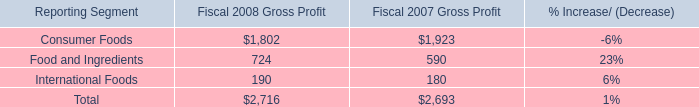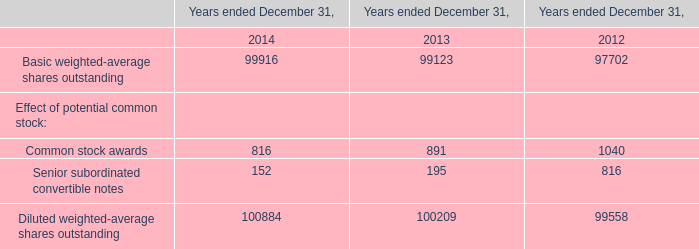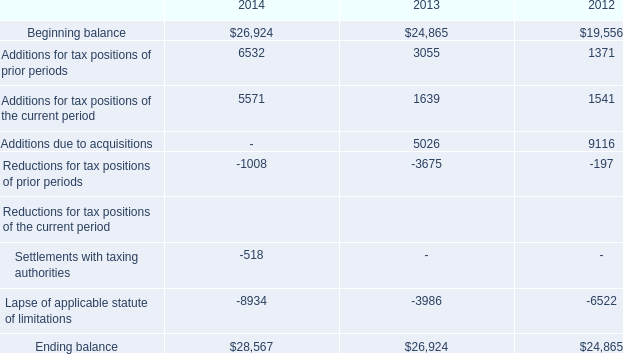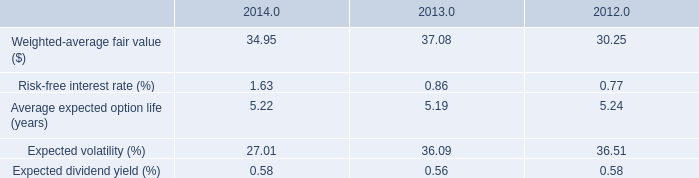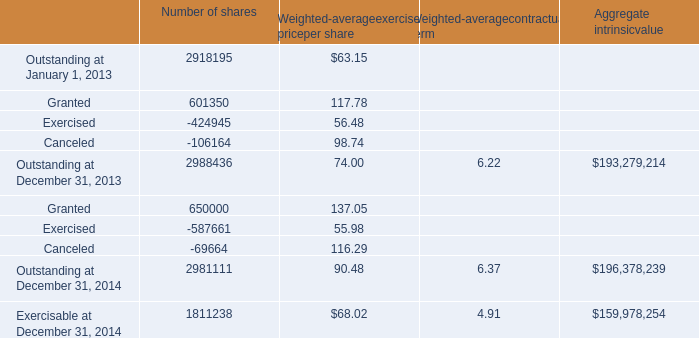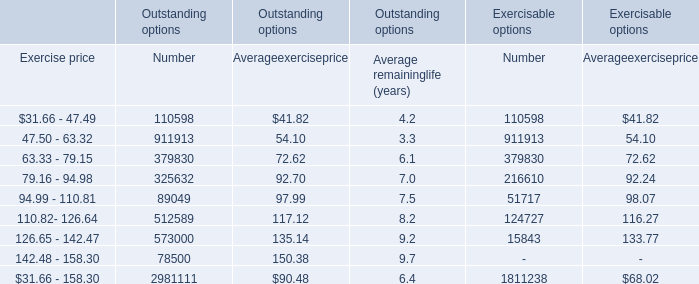If Weighted-average fair value ($) develops with the same growth rate in 2014, what will it reach in 2015? 
Computations: (34.95 * (1 + ((34.95 - 37.08) / 37.08)))
Answer: 32.94235. 